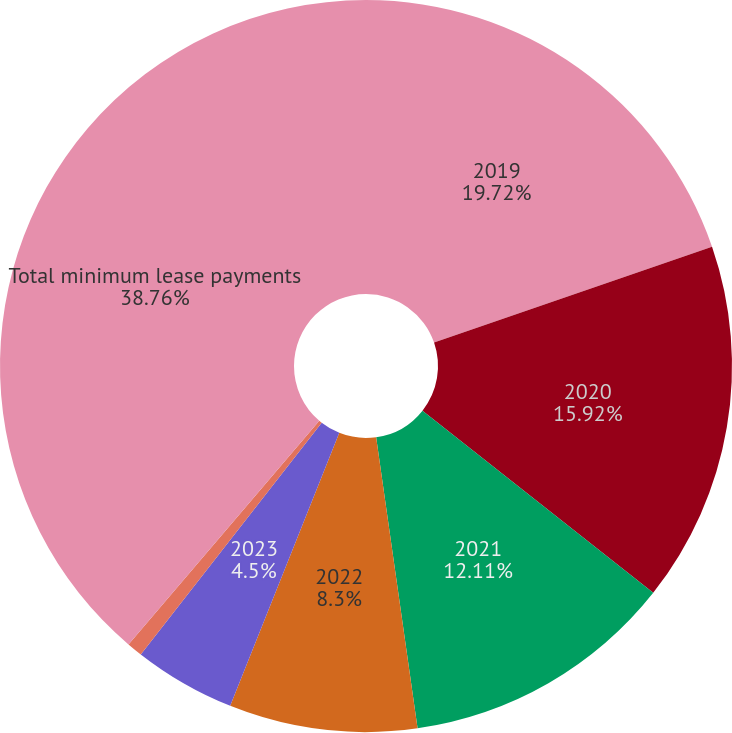Convert chart. <chart><loc_0><loc_0><loc_500><loc_500><pie_chart><fcel>2019<fcel>2020<fcel>2021<fcel>2022<fcel>2023<fcel>Thereafter<fcel>Total minimum lease payments<nl><fcel>19.72%<fcel>15.92%<fcel>12.11%<fcel>8.3%<fcel>4.5%<fcel>0.69%<fcel>38.76%<nl></chart> 